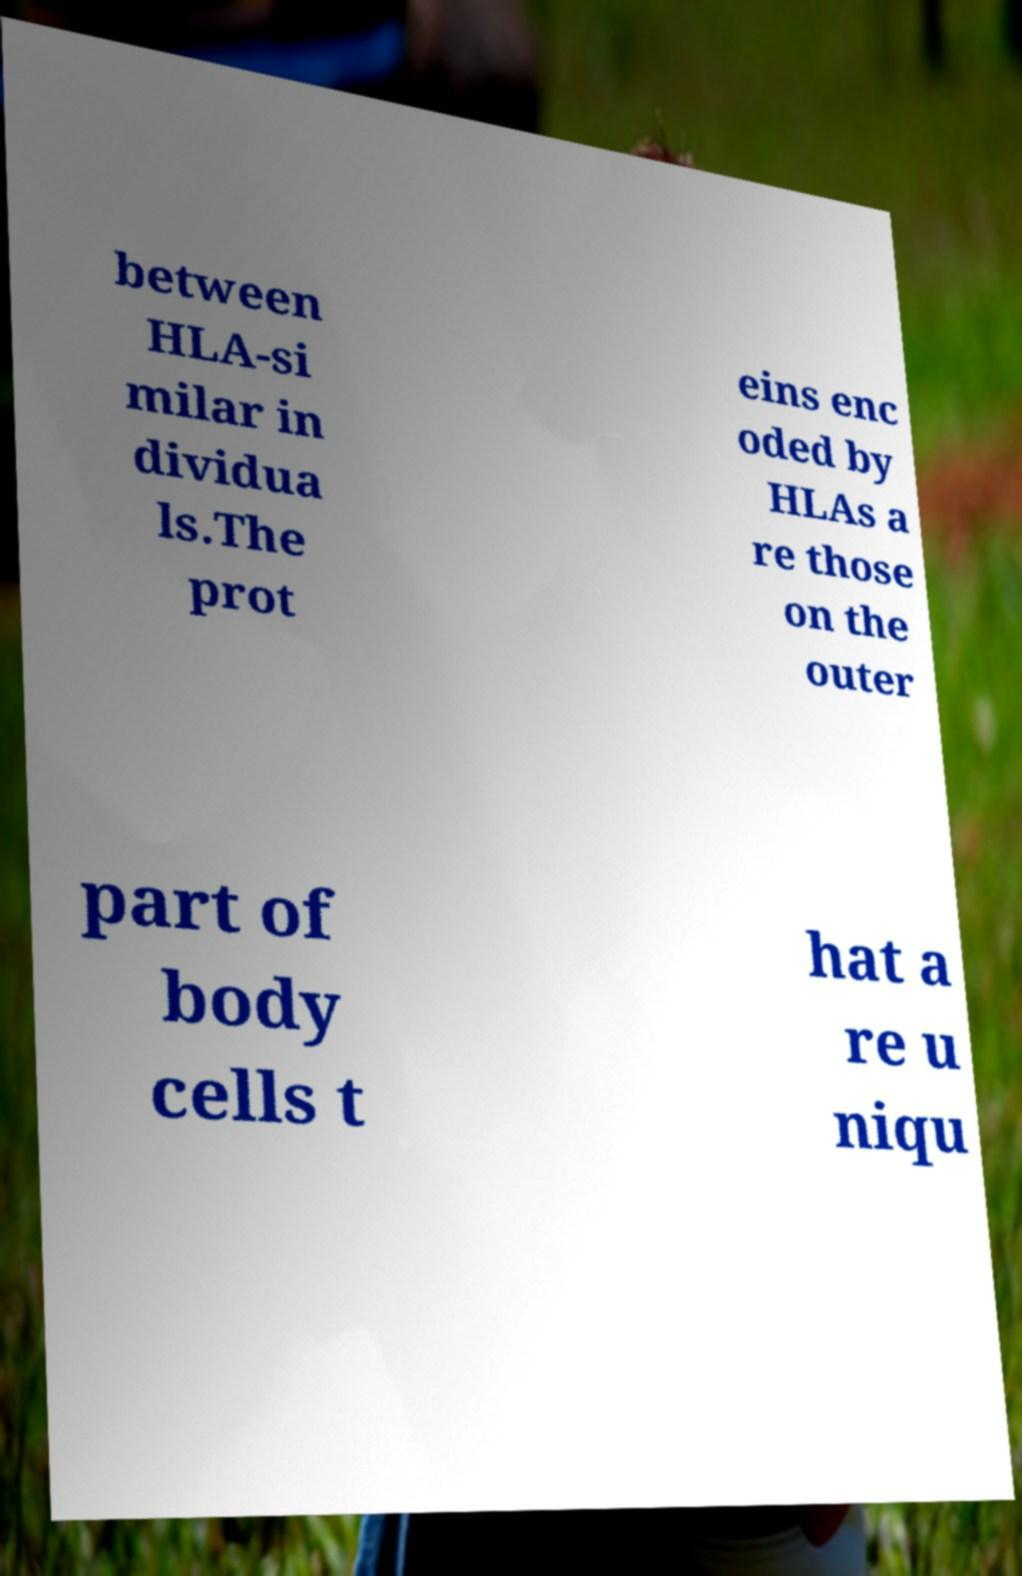Can you read and provide the text displayed in the image?This photo seems to have some interesting text. Can you extract and type it out for me? between HLA-si milar in dividua ls.The prot eins enc oded by HLAs a re those on the outer part of body cells t hat a re u niqu 